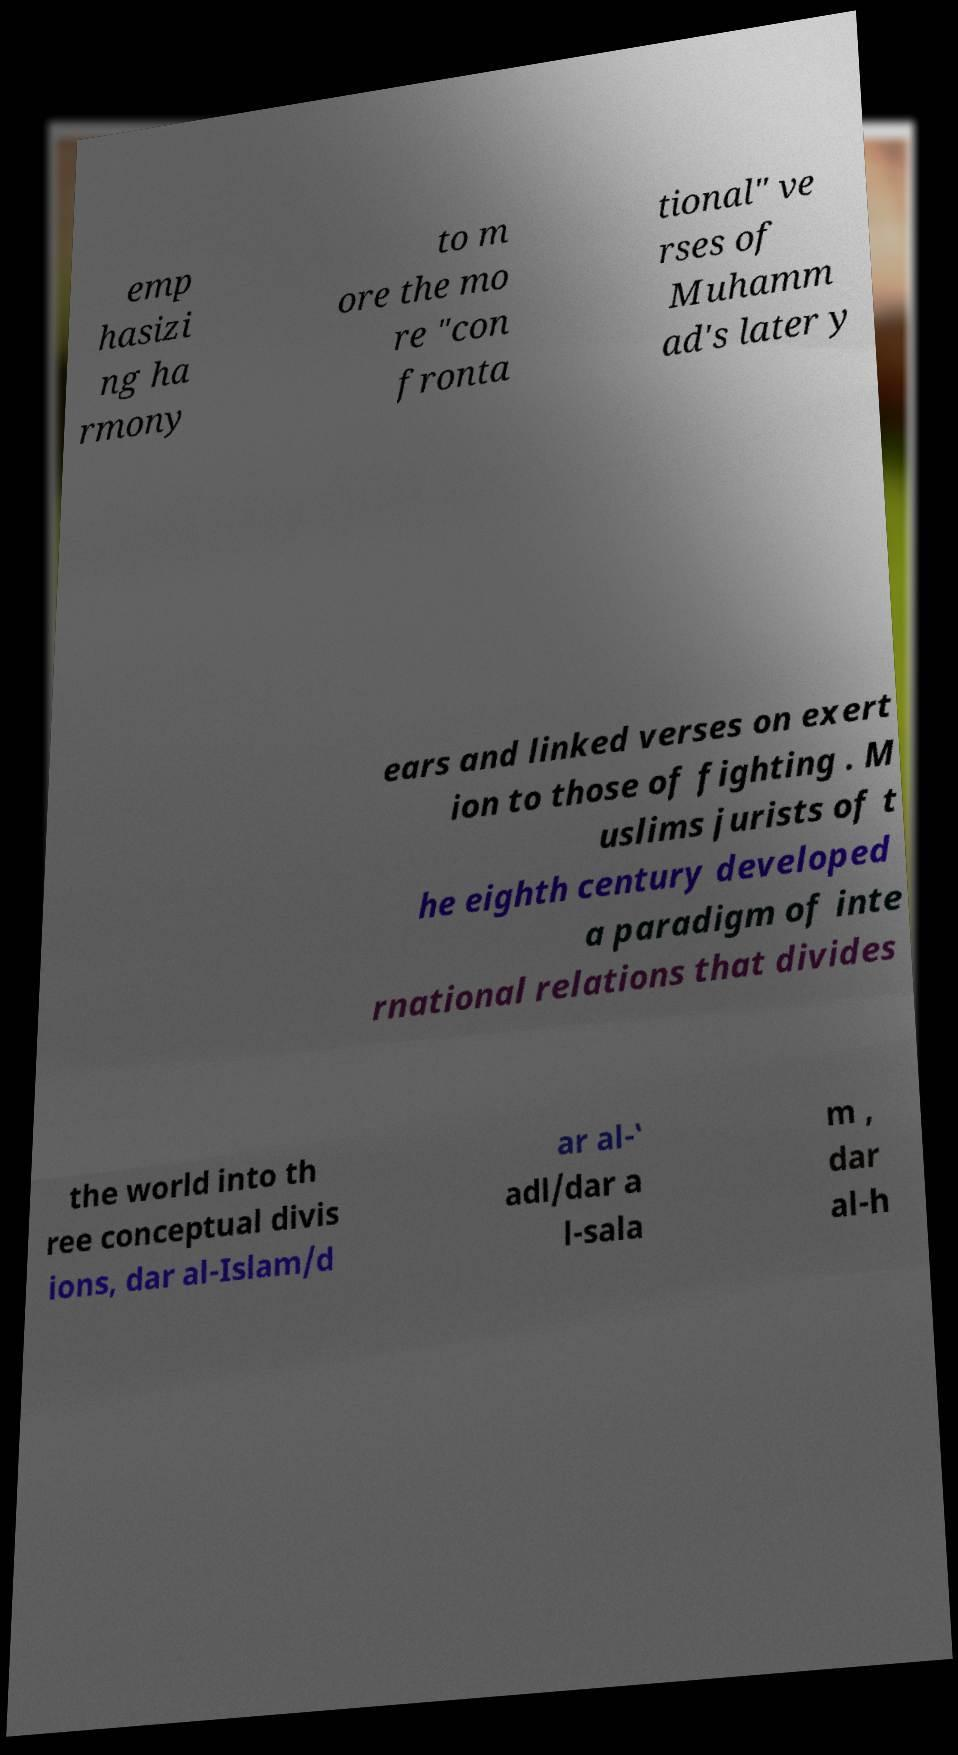Can you read and provide the text displayed in the image?This photo seems to have some interesting text. Can you extract and type it out for me? emp hasizi ng ha rmony to m ore the mo re "con fronta tional" ve rses of Muhamm ad's later y ears and linked verses on exert ion to those of fighting . M uslims jurists of t he eighth century developed a paradigm of inte rnational relations that divides the world into th ree conceptual divis ions, dar al-Islam/d ar al-‛ adl/dar a l-sala m , dar al-h 